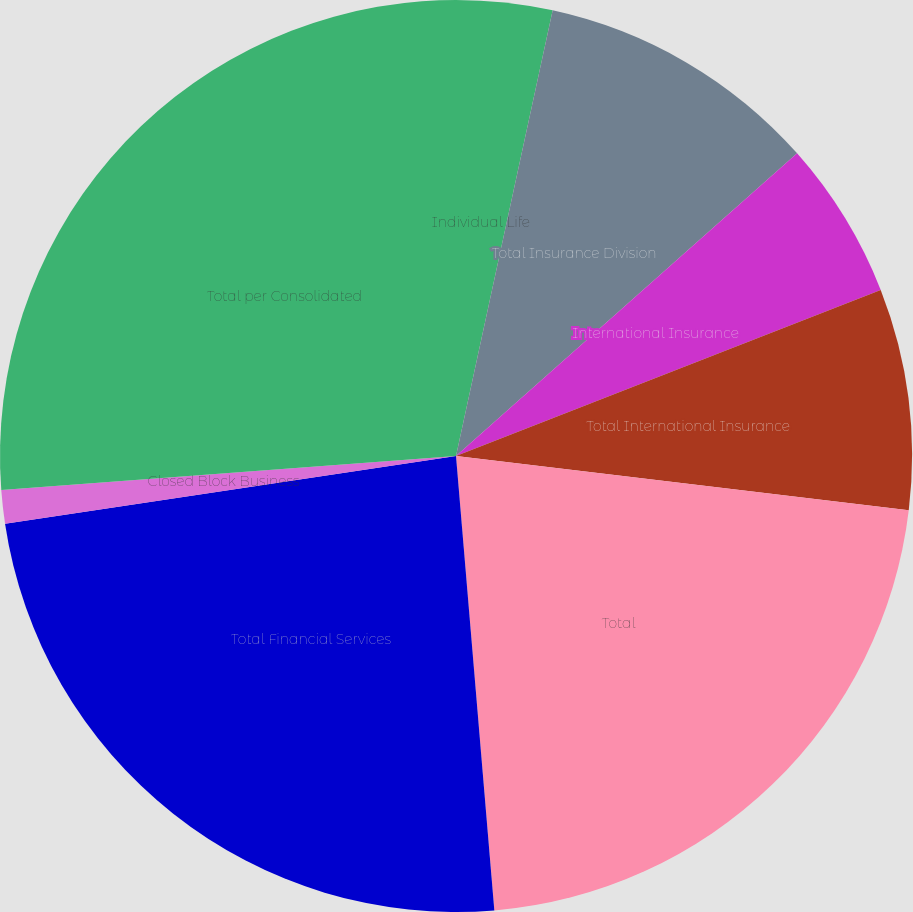Convert chart. <chart><loc_0><loc_0><loc_500><loc_500><pie_chart><fcel>Individual Life<fcel>Total Insurance Division<fcel>International Insurance<fcel>Total International Insurance<fcel>Total<fcel>Total Financial Services<fcel>Closed Block Business<fcel>Total per Consolidated<nl><fcel>3.4%<fcel>10.05%<fcel>5.62%<fcel>7.83%<fcel>21.76%<fcel>23.97%<fcel>1.18%<fcel>26.19%<nl></chart> 